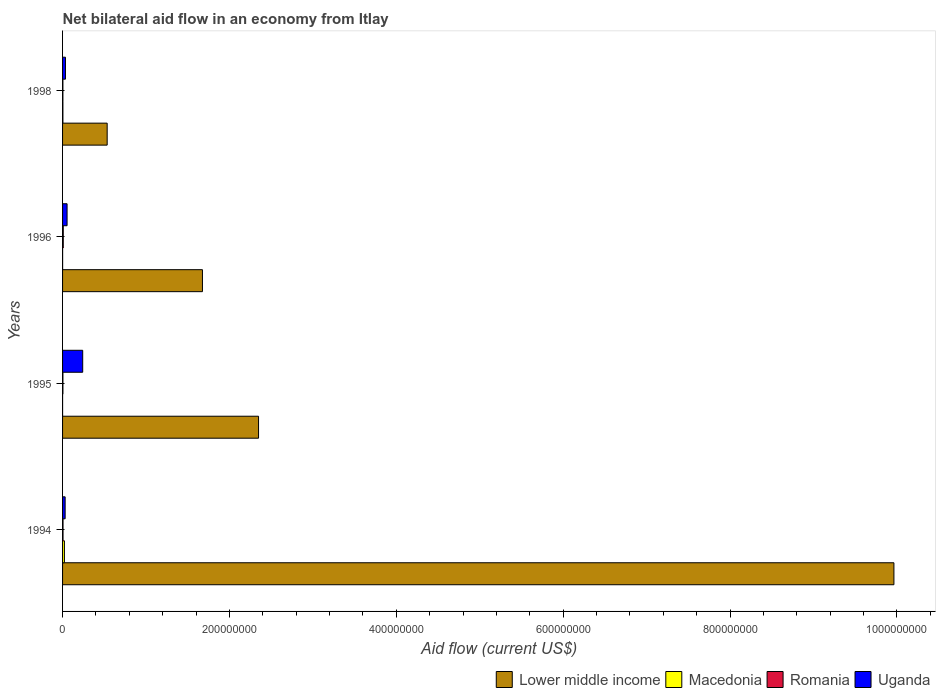Are the number of bars on each tick of the Y-axis equal?
Your response must be concise. Yes. How many bars are there on the 2nd tick from the top?
Offer a very short reply. 4. How many bars are there on the 2nd tick from the bottom?
Give a very brief answer. 4. Across all years, what is the maximum net bilateral aid flow in Romania?
Your response must be concise. 8.40e+05. Across all years, what is the minimum net bilateral aid flow in Lower middle income?
Make the answer very short. 5.34e+07. In which year was the net bilateral aid flow in Macedonia minimum?
Give a very brief answer. 1995. What is the total net bilateral aid flow in Lower middle income in the graph?
Offer a very short reply. 1.45e+09. What is the difference between the net bilateral aid flow in Uganda in 1994 and that in 1995?
Your answer should be very brief. -2.11e+07. What is the difference between the net bilateral aid flow in Uganda in 1994 and the net bilateral aid flow in Macedonia in 1998?
Offer a terse response. 2.67e+06. What is the average net bilateral aid flow in Romania per year?
Make the answer very short. 5.58e+05. In the year 1994, what is the difference between the net bilateral aid flow in Lower middle income and net bilateral aid flow in Romania?
Make the answer very short. 9.96e+08. In how many years, is the net bilateral aid flow in Macedonia greater than 560000000 US$?
Ensure brevity in your answer.  0. What is the ratio of the net bilateral aid flow in Uganda in 1995 to that in 1996?
Provide a succinct answer. 4.47. Is the net bilateral aid flow in Uganda in 1996 less than that in 1998?
Give a very brief answer. No. What is the difference between the highest and the second highest net bilateral aid flow in Macedonia?
Make the answer very short. 1.81e+06. What is the difference between the highest and the lowest net bilateral aid flow in Romania?
Make the answer very short. 4.30e+05. In how many years, is the net bilateral aid flow in Romania greater than the average net bilateral aid flow in Romania taken over all years?
Offer a terse response. 2. Is the sum of the net bilateral aid flow in Uganda in 1994 and 1995 greater than the maximum net bilateral aid flow in Lower middle income across all years?
Offer a terse response. No. Is it the case that in every year, the sum of the net bilateral aid flow in Macedonia and net bilateral aid flow in Uganda is greater than the sum of net bilateral aid flow in Lower middle income and net bilateral aid flow in Romania?
Keep it short and to the point. Yes. What does the 3rd bar from the top in 1994 represents?
Ensure brevity in your answer.  Macedonia. What does the 1st bar from the bottom in 1996 represents?
Provide a succinct answer. Lower middle income. Are all the bars in the graph horizontal?
Provide a succinct answer. Yes. Does the graph contain any zero values?
Offer a terse response. No. Does the graph contain grids?
Your answer should be very brief. No. How many legend labels are there?
Provide a short and direct response. 4. What is the title of the graph?
Your answer should be very brief. Net bilateral aid flow in an economy from Itlay. Does "Australia" appear as one of the legend labels in the graph?
Make the answer very short. No. What is the label or title of the X-axis?
Your answer should be compact. Aid flow (current US$). What is the Aid flow (current US$) in Lower middle income in 1994?
Ensure brevity in your answer.  9.96e+08. What is the Aid flow (current US$) of Macedonia in 1994?
Keep it short and to the point. 2.22e+06. What is the Aid flow (current US$) of Romania in 1994?
Your answer should be compact. 5.60e+05. What is the Aid flow (current US$) of Uganda in 1994?
Your answer should be compact. 3.08e+06. What is the Aid flow (current US$) of Lower middle income in 1995?
Offer a terse response. 2.35e+08. What is the Aid flow (current US$) in Uganda in 1995?
Ensure brevity in your answer.  2.41e+07. What is the Aid flow (current US$) in Lower middle income in 1996?
Give a very brief answer. 1.68e+08. What is the Aid flow (current US$) in Macedonia in 1996?
Keep it short and to the point. 6.00e+04. What is the Aid flow (current US$) of Romania in 1996?
Your answer should be very brief. 8.40e+05. What is the Aid flow (current US$) in Uganda in 1996?
Offer a terse response. 5.40e+06. What is the Aid flow (current US$) in Lower middle income in 1998?
Give a very brief answer. 5.34e+07. What is the Aid flow (current US$) in Romania in 1998?
Provide a short and direct response. 4.10e+05. What is the Aid flow (current US$) in Uganda in 1998?
Provide a succinct answer. 3.48e+06. Across all years, what is the maximum Aid flow (current US$) of Lower middle income?
Make the answer very short. 9.96e+08. Across all years, what is the maximum Aid flow (current US$) of Macedonia?
Offer a terse response. 2.22e+06. Across all years, what is the maximum Aid flow (current US$) of Romania?
Keep it short and to the point. 8.40e+05. Across all years, what is the maximum Aid flow (current US$) of Uganda?
Offer a terse response. 2.41e+07. Across all years, what is the minimum Aid flow (current US$) in Lower middle income?
Your answer should be compact. 5.34e+07. Across all years, what is the minimum Aid flow (current US$) in Macedonia?
Ensure brevity in your answer.  2.00e+04. Across all years, what is the minimum Aid flow (current US$) of Romania?
Your response must be concise. 4.10e+05. Across all years, what is the minimum Aid flow (current US$) in Uganda?
Give a very brief answer. 3.08e+06. What is the total Aid flow (current US$) of Lower middle income in the graph?
Ensure brevity in your answer.  1.45e+09. What is the total Aid flow (current US$) in Macedonia in the graph?
Make the answer very short. 2.71e+06. What is the total Aid flow (current US$) in Romania in the graph?
Offer a terse response. 2.23e+06. What is the total Aid flow (current US$) of Uganda in the graph?
Give a very brief answer. 3.61e+07. What is the difference between the Aid flow (current US$) of Lower middle income in 1994 and that in 1995?
Offer a very short reply. 7.61e+08. What is the difference between the Aid flow (current US$) in Macedonia in 1994 and that in 1995?
Your answer should be compact. 2.20e+06. What is the difference between the Aid flow (current US$) of Romania in 1994 and that in 1995?
Your response must be concise. 1.40e+05. What is the difference between the Aid flow (current US$) in Uganda in 1994 and that in 1995?
Your response must be concise. -2.11e+07. What is the difference between the Aid flow (current US$) of Lower middle income in 1994 and that in 1996?
Give a very brief answer. 8.29e+08. What is the difference between the Aid flow (current US$) in Macedonia in 1994 and that in 1996?
Your answer should be compact. 2.16e+06. What is the difference between the Aid flow (current US$) in Romania in 1994 and that in 1996?
Ensure brevity in your answer.  -2.80e+05. What is the difference between the Aid flow (current US$) in Uganda in 1994 and that in 1996?
Your response must be concise. -2.32e+06. What is the difference between the Aid flow (current US$) in Lower middle income in 1994 and that in 1998?
Your answer should be very brief. 9.43e+08. What is the difference between the Aid flow (current US$) in Macedonia in 1994 and that in 1998?
Make the answer very short. 1.81e+06. What is the difference between the Aid flow (current US$) of Uganda in 1994 and that in 1998?
Offer a terse response. -4.00e+05. What is the difference between the Aid flow (current US$) in Lower middle income in 1995 and that in 1996?
Give a very brief answer. 6.72e+07. What is the difference between the Aid flow (current US$) in Macedonia in 1995 and that in 1996?
Give a very brief answer. -4.00e+04. What is the difference between the Aid flow (current US$) in Romania in 1995 and that in 1996?
Give a very brief answer. -4.20e+05. What is the difference between the Aid flow (current US$) of Uganda in 1995 and that in 1996?
Keep it short and to the point. 1.87e+07. What is the difference between the Aid flow (current US$) of Lower middle income in 1995 and that in 1998?
Your answer should be compact. 1.81e+08. What is the difference between the Aid flow (current US$) in Macedonia in 1995 and that in 1998?
Ensure brevity in your answer.  -3.90e+05. What is the difference between the Aid flow (current US$) of Romania in 1995 and that in 1998?
Your response must be concise. 10000. What is the difference between the Aid flow (current US$) in Uganda in 1995 and that in 1998?
Make the answer very short. 2.07e+07. What is the difference between the Aid flow (current US$) of Lower middle income in 1996 and that in 1998?
Your answer should be compact. 1.14e+08. What is the difference between the Aid flow (current US$) in Macedonia in 1996 and that in 1998?
Your answer should be very brief. -3.50e+05. What is the difference between the Aid flow (current US$) in Uganda in 1996 and that in 1998?
Offer a very short reply. 1.92e+06. What is the difference between the Aid flow (current US$) of Lower middle income in 1994 and the Aid flow (current US$) of Macedonia in 1995?
Make the answer very short. 9.96e+08. What is the difference between the Aid flow (current US$) of Lower middle income in 1994 and the Aid flow (current US$) of Romania in 1995?
Your answer should be compact. 9.96e+08. What is the difference between the Aid flow (current US$) of Lower middle income in 1994 and the Aid flow (current US$) of Uganda in 1995?
Provide a short and direct response. 9.72e+08. What is the difference between the Aid flow (current US$) in Macedonia in 1994 and the Aid flow (current US$) in Romania in 1995?
Offer a terse response. 1.80e+06. What is the difference between the Aid flow (current US$) of Macedonia in 1994 and the Aid flow (current US$) of Uganda in 1995?
Offer a terse response. -2.19e+07. What is the difference between the Aid flow (current US$) in Romania in 1994 and the Aid flow (current US$) in Uganda in 1995?
Offer a terse response. -2.36e+07. What is the difference between the Aid flow (current US$) of Lower middle income in 1994 and the Aid flow (current US$) of Macedonia in 1996?
Keep it short and to the point. 9.96e+08. What is the difference between the Aid flow (current US$) in Lower middle income in 1994 and the Aid flow (current US$) in Romania in 1996?
Offer a very short reply. 9.96e+08. What is the difference between the Aid flow (current US$) in Lower middle income in 1994 and the Aid flow (current US$) in Uganda in 1996?
Give a very brief answer. 9.91e+08. What is the difference between the Aid flow (current US$) of Macedonia in 1994 and the Aid flow (current US$) of Romania in 1996?
Ensure brevity in your answer.  1.38e+06. What is the difference between the Aid flow (current US$) of Macedonia in 1994 and the Aid flow (current US$) of Uganda in 1996?
Your answer should be very brief. -3.18e+06. What is the difference between the Aid flow (current US$) of Romania in 1994 and the Aid flow (current US$) of Uganda in 1996?
Offer a terse response. -4.84e+06. What is the difference between the Aid flow (current US$) of Lower middle income in 1994 and the Aid flow (current US$) of Macedonia in 1998?
Offer a very short reply. 9.96e+08. What is the difference between the Aid flow (current US$) in Lower middle income in 1994 and the Aid flow (current US$) in Romania in 1998?
Your response must be concise. 9.96e+08. What is the difference between the Aid flow (current US$) of Lower middle income in 1994 and the Aid flow (current US$) of Uganda in 1998?
Keep it short and to the point. 9.93e+08. What is the difference between the Aid flow (current US$) in Macedonia in 1994 and the Aid flow (current US$) in Romania in 1998?
Provide a succinct answer. 1.81e+06. What is the difference between the Aid flow (current US$) in Macedonia in 1994 and the Aid flow (current US$) in Uganda in 1998?
Offer a very short reply. -1.26e+06. What is the difference between the Aid flow (current US$) of Romania in 1994 and the Aid flow (current US$) of Uganda in 1998?
Make the answer very short. -2.92e+06. What is the difference between the Aid flow (current US$) of Lower middle income in 1995 and the Aid flow (current US$) of Macedonia in 1996?
Provide a short and direct response. 2.35e+08. What is the difference between the Aid flow (current US$) in Lower middle income in 1995 and the Aid flow (current US$) in Romania in 1996?
Your answer should be very brief. 2.34e+08. What is the difference between the Aid flow (current US$) in Lower middle income in 1995 and the Aid flow (current US$) in Uganda in 1996?
Your response must be concise. 2.29e+08. What is the difference between the Aid flow (current US$) in Macedonia in 1995 and the Aid flow (current US$) in Romania in 1996?
Your answer should be very brief. -8.20e+05. What is the difference between the Aid flow (current US$) in Macedonia in 1995 and the Aid flow (current US$) in Uganda in 1996?
Give a very brief answer. -5.38e+06. What is the difference between the Aid flow (current US$) in Romania in 1995 and the Aid flow (current US$) in Uganda in 1996?
Keep it short and to the point. -4.98e+06. What is the difference between the Aid flow (current US$) of Lower middle income in 1995 and the Aid flow (current US$) of Macedonia in 1998?
Your response must be concise. 2.34e+08. What is the difference between the Aid flow (current US$) of Lower middle income in 1995 and the Aid flow (current US$) of Romania in 1998?
Provide a succinct answer. 2.34e+08. What is the difference between the Aid flow (current US$) in Lower middle income in 1995 and the Aid flow (current US$) in Uganda in 1998?
Provide a succinct answer. 2.31e+08. What is the difference between the Aid flow (current US$) of Macedonia in 1995 and the Aid flow (current US$) of Romania in 1998?
Provide a short and direct response. -3.90e+05. What is the difference between the Aid flow (current US$) of Macedonia in 1995 and the Aid flow (current US$) of Uganda in 1998?
Offer a very short reply. -3.46e+06. What is the difference between the Aid flow (current US$) in Romania in 1995 and the Aid flow (current US$) in Uganda in 1998?
Your answer should be compact. -3.06e+06. What is the difference between the Aid flow (current US$) in Lower middle income in 1996 and the Aid flow (current US$) in Macedonia in 1998?
Your answer should be compact. 1.67e+08. What is the difference between the Aid flow (current US$) of Lower middle income in 1996 and the Aid flow (current US$) of Romania in 1998?
Keep it short and to the point. 1.67e+08. What is the difference between the Aid flow (current US$) in Lower middle income in 1996 and the Aid flow (current US$) in Uganda in 1998?
Keep it short and to the point. 1.64e+08. What is the difference between the Aid flow (current US$) of Macedonia in 1996 and the Aid flow (current US$) of Romania in 1998?
Offer a terse response. -3.50e+05. What is the difference between the Aid flow (current US$) of Macedonia in 1996 and the Aid flow (current US$) of Uganda in 1998?
Offer a terse response. -3.42e+06. What is the difference between the Aid flow (current US$) in Romania in 1996 and the Aid flow (current US$) in Uganda in 1998?
Your answer should be very brief. -2.64e+06. What is the average Aid flow (current US$) of Lower middle income per year?
Provide a succinct answer. 3.63e+08. What is the average Aid flow (current US$) in Macedonia per year?
Your response must be concise. 6.78e+05. What is the average Aid flow (current US$) in Romania per year?
Offer a very short reply. 5.58e+05. What is the average Aid flow (current US$) in Uganda per year?
Offer a terse response. 9.02e+06. In the year 1994, what is the difference between the Aid flow (current US$) of Lower middle income and Aid flow (current US$) of Macedonia?
Offer a very short reply. 9.94e+08. In the year 1994, what is the difference between the Aid flow (current US$) of Lower middle income and Aid flow (current US$) of Romania?
Ensure brevity in your answer.  9.96e+08. In the year 1994, what is the difference between the Aid flow (current US$) in Lower middle income and Aid flow (current US$) in Uganda?
Your response must be concise. 9.93e+08. In the year 1994, what is the difference between the Aid flow (current US$) of Macedonia and Aid flow (current US$) of Romania?
Offer a very short reply. 1.66e+06. In the year 1994, what is the difference between the Aid flow (current US$) in Macedonia and Aid flow (current US$) in Uganda?
Your answer should be very brief. -8.60e+05. In the year 1994, what is the difference between the Aid flow (current US$) in Romania and Aid flow (current US$) in Uganda?
Ensure brevity in your answer.  -2.52e+06. In the year 1995, what is the difference between the Aid flow (current US$) of Lower middle income and Aid flow (current US$) of Macedonia?
Provide a succinct answer. 2.35e+08. In the year 1995, what is the difference between the Aid flow (current US$) in Lower middle income and Aid flow (current US$) in Romania?
Offer a very short reply. 2.34e+08. In the year 1995, what is the difference between the Aid flow (current US$) in Lower middle income and Aid flow (current US$) in Uganda?
Offer a terse response. 2.11e+08. In the year 1995, what is the difference between the Aid flow (current US$) in Macedonia and Aid flow (current US$) in Romania?
Provide a succinct answer. -4.00e+05. In the year 1995, what is the difference between the Aid flow (current US$) in Macedonia and Aid flow (current US$) in Uganda?
Your answer should be compact. -2.41e+07. In the year 1995, what is the difference between the Aid flow (current US$) of Romania and Aid flow (current US$) of Uganda?
Provide a short and direct response. -2.37e+07. In the year 1996, what is the difference between the Aid flow (current US$) of Lower middle income and Aid flow (current US$) of Macedonia?
Ensure brevity in your answer.  1.68e+08. In the year 1996, what is the difference between the Aid flow (current US$) in Lower middle income and Aid flow (current US$) in Romania?
Provide a succinct answer. 1.67e+08. In the year 1996, what is the difference between the Aid flow (current US$) of Lower middle income and Aid flow (current US$) of Uganda?
Give a very brief answer. 1.62e+08. In the year 1996, what is the difference between the Aid flow (current US$) in Macedonia and Aid flow (current US$) in Romania?
Your response must be concise. -7.80e+05. In the year 1996, what is the difference between the Aid flow (current US$) in Macedonia and Aid flow (current US$) in Uganda?
Ensure brevity in your answer.  -5.34e+06. In the year 1996, what is the difference between the Aid flow (current US$) of Romania and Aid flow (current US$) of Uganda?
Your answer should be very brief. -4.56e+06. In the year 1998, what is the difference between the Aid flow (current US$) in Lower middle income and Aid flow (current US$) in Macedonia?
Give a very brief answer. 5.30e+07. In the year 1998, what is the difference between the Aid flow (current US$) in Lower middle income and Aid flow (current US$) in Romania?
Provide a short and direct response. 5.30e+07. In the year 1998, what is the difference between the Aid flow (current US$) of Lower middle income and Aid flow (current US$) of Uganda?
Offer a very short reply. 5.00e+07. In the year 1998, what is the difference between the Aid flow (current US$) in Macedonia and Aid flow (current US$) in Romania?
Ensure brevity in your answer.  0. In the year 1998, what is the difference between the Aid flow (current US$) in Macedonia and Aid flow (current US$) in Uganda?
Ensure brevity in your answer.  -3.07e+06. In the year 1998, what is the difference between the Aid flow (current US$) in Romania and Aid flow (current US$) in Uganda?
Give a very brief answer. -3.07e+06. What is the ratio of the Aid flow (current US$) in Lower middle income in 1994 to that in 1995?
Your response must be concise. 4.24. What is the ratio of the Aid flow (current US$) of Macedonia in 1994 to that in 1995?
Offer a terse response. 111. What is the ratio of the Aid flow (current US$) in Romania in 1994 to that in 1995?
Make the answer very short. 1.33. What is the ratio of the Aid flow (current US$) of Uganda in 1994 to that in 1995?
Make the answer very short. 0.13. What is the ratio of the Aid flow (current US$) in Lower middle income in 1994 to that in 1996?
Give a very brief answer. 5.94. What is the ratio of the Aid flow (current US$) in Macedonia in 1994 to that in 1996?
Make the answer very short. 37. What is the ratio of the Aid flow (current US$) in Romania in 1994 to that in 1996?
Your response must be concise. 0.67. What is the ratio of the Aid flow (current US$) in Uganda in 1994 to that in 1996?
Provide a short and direct response. 0.57. What is the ratio of the Aid flow (current US$) in Lower middle income in 1994 to that in 1998?
Your answer should be very brief. 18.64. What is the ratio of the Aid flow (current US$) in Macedonia in 1994 to that in 1998?
Offer a terse response. 5.41. What is the ratio of the Aid flow (current US$) in Romania in 1994 to that in 1998?
Offer a very short reply. 1.37. What is the ratio of the Aid flow (current US$) in Uganda in 1994 to that in 1998?
Make the answer very short. 0.89. What is the ratio of the Aid flow (current US$) of Lower middle income in 1995 to that in 1996?
Offer a very short reply. 1.4. What is the ratio of the Aid flow (current US$) in Macedonia in 1995 to that in 1996?
Ensure brevity in your answer.  0.33. What is the ratio of the Aid flow (current US$) in Uganda in 1995 to that in 1996?
Ensure brevity in your answer.  4.47. What is the ratio of the Aid flow (current US$) of Lower middle income in 1995 to that in 1998?
Offer a terse response. 4.39. What is the ratio of the Aid flow (current US$) in Macedonia in 1995 to that in 1998?
Provide a short and direct response. 0.05. What is the ratio of the Aid flow (current US$) in Romania in 1995 to that in 1998?
Your response must be concise. 1.02. What is the ratio of the Aid flow (current US$) in Uganda in 1995 to that in 1998?
Provide a succinct answer. 6.94. What is the ratio of the Aid flow (current US$) in Lower middle income in 1996 to that in 1998?
Make the answer very short. 3.14. What is the ratio of the Aid flow (current US$) in Macedonia in 1996 to that in 1998?
Your response must be concise. 0.15. What is the ratio of the Aid flow (current US$) in Romania in 1996 to that in 1998?
Keep it short and to the point. 2.05. What is the ratio of the Aid flow (current US$) in Uganda in 1996 to that in 1998?
Make the answer very short. 1.55. What is the difference between the highest and the second highest Aid flow (current US$) in Lower middle income?
Ensure brevity in your answer.  7.61e+08. What is the difference between the highest and the second highest Aid flow (current US$) in Macedonia?
Give a very brief answer. 1.81e+06. What is the difference between the highest and the second highest Aid flow (current US$) in Uganda?
Your answer should be compact. 1.87e+07. What is the difference between the highest and the lowest Aid flow (current US$) of Lower middle income?
Keep it short and to the point. 9.43e+08. What is the difference between the highest and the lowest Aid flow (current US$) of Macedonia?
Provide a short and direct response. 2.20e+06. What is the difference between the highest and the lowest Aid flow (current US$) in Romania?
Your response must be concise. 4.30e+05. What is the difference between the highest and the lowest Aid flow (current US$) in Uganda?
Provide a succinct answer. 2.11e+07. 